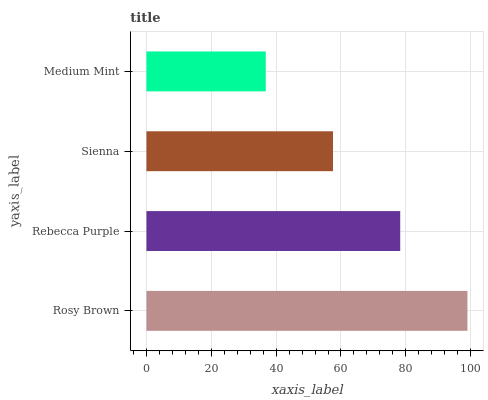Is Medium Mint the minimum?
Answer yes or no. Yes. Is Rosy Brown the maximum?
Answer yes or no. Yes. Is Rebecca Purple the minimum?
Answer yes or no. No. Is Rebecca Purple the maximum?
Answer yes or no. No. Is Rosy Brown greater than Rebecca Purple?
Answer yes or no. Yes. Is Rebecca Purple less than Rosy Brown?
Answer yes or no. Yes. Is Rebecca Purple greater than Rosy Brown?
Answer yes or no. No. Is Rosy Brown less than Rebecca Purple?
Answer yes or no. No. Is Rebecca Purple the high median?
Answer yes or no. Yes. Is Sienna the low median?
Answer yes or no. Yes. Is Medium Mint the high median?
Answer yes or no. No. Is Rebecca Purple the low median?
Answer yes or no. No. 